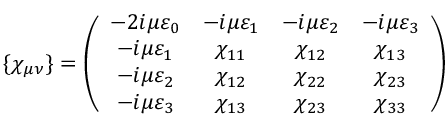<formula> <loc_0><loc_0><loc_500><loc_500>\{ \chi _ { \mu \nu } \} = \left ( \begin{array} { c c c c } { { - 2 i \mu \varepsilon _ { 0 } } } & { { - i \mu \varepsilon _ { 1 } } } & { { - i \mu \varepsilon _ { 2 } } } & { { - i \mu \varepsilon _ { 3 } } } \\ { { - i \mu \varepsilon _ { 1 } } } & { { \chi _ { 1 1 } } } & { { \chi _ { 1 2 } } } & { { \chi _ { 1 3 } } } \\ { { - i \mu \varepsilon _ { 2 } } } & { { \chi _ { 1 2 } } } & { { \chi _ { 2 2 } } } & { { \chi _ { 2 3 } } } \\ { { - i \mu \varepsilon _ { 3 } } } & { { \chi _ { 1 3 } } } & { { \chi _ { 2 3 } } } & { { \chi _ { 3 3 } } } \end{array} \right )</formula> 